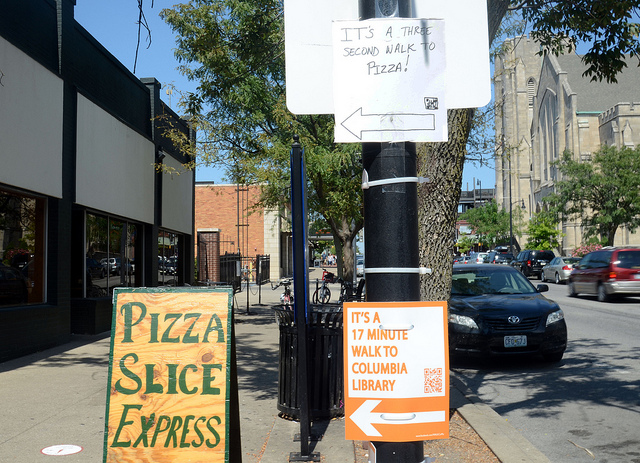Read all the text in this image. PIZZA SLICE EXPRESS WALK COLUMBIA LIBRARY TO MINUTE 17 A IT'S SECOND PIZZA NALK TO THREE A IT'S 